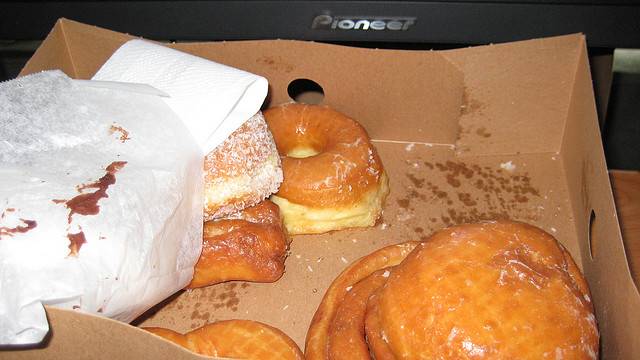Please identify all text content in this image. Pioneer 